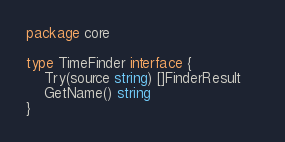<code> <loc_0><loc_0><loc_500><loc_500><_Go_>package core

type TimeFinder interface {
	Try(source string) []FinderResult	
	GetName() string
}
</code> 